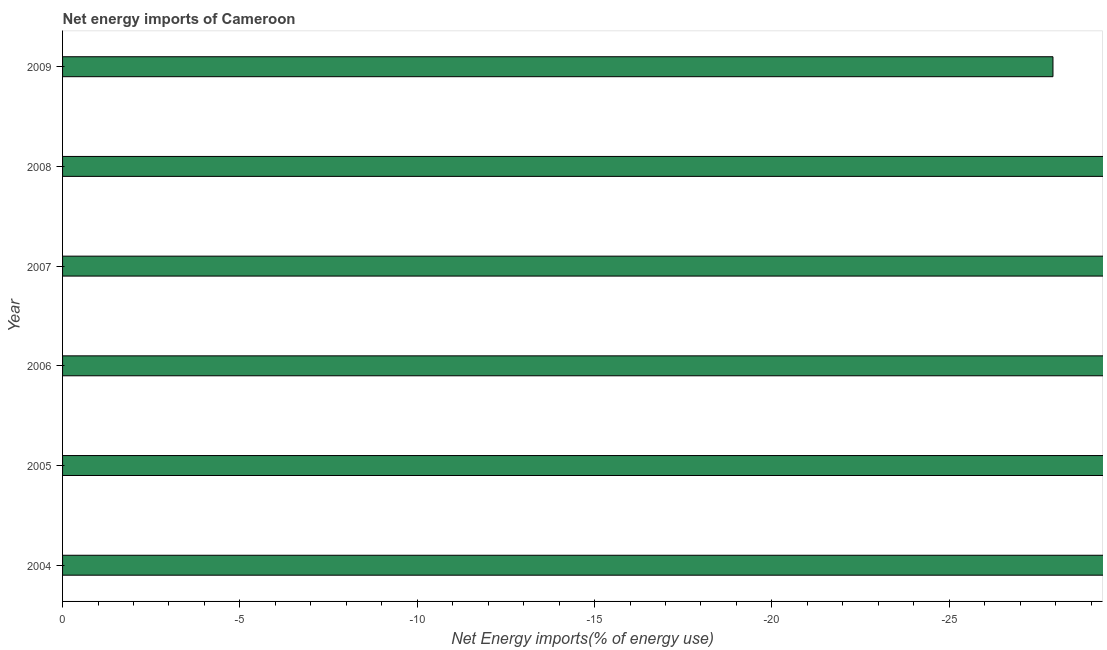Does the graph contain any zero values?
Make the answer very short. Yes. Does the graph contain grids?
Your answer should be compact. No. What is the title of the graph?
Provide a succinct answer. Net energy imports of Cameroon. What is the label or title of the X-axis?
Keep it short and to the point. Net Energy imports(% of energy use). What is the label or title of the Y-axis?
Your answer should be compact. Year. What is the energy imports in 2009?
Your answer should be very brief. 0. In how many years, is the energy imports greater than the average energy imports taken over all years?
Your answer should be compact. 0. How many bars are there?
Your answer should be very brief. 0. Are all the bars in the graph horizontal?
Provide a short and direct response. Yes. How many years are there in the graph?
Ensure brevity in your answer.  6. What is the difference between two consecutive major ticks on the X-axis?
Your answer should be compact. 5. Are the values on the major ticks of X-axis written in scientific E-notation?
Provide a short and direct response. No. What is the Net Energy imports(% of energy use) in 2004?
Give a very brief answer. 0. What is the Net Energy imports(% of energy use) of 2007?
Offer a very short reply. 0. What is the Net Energy imports(% of energy use) of 2008?
Offer a very short reply. 0. 